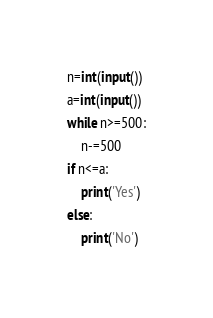Convert code to text. <code><loc_0><loc_0><loc_500><loc_500><_Python_>n=int(input())
a=int(input())
while n>=500:
    n-=500
if n<=a:
    print('Yes')
else:
    print('No') </code> 